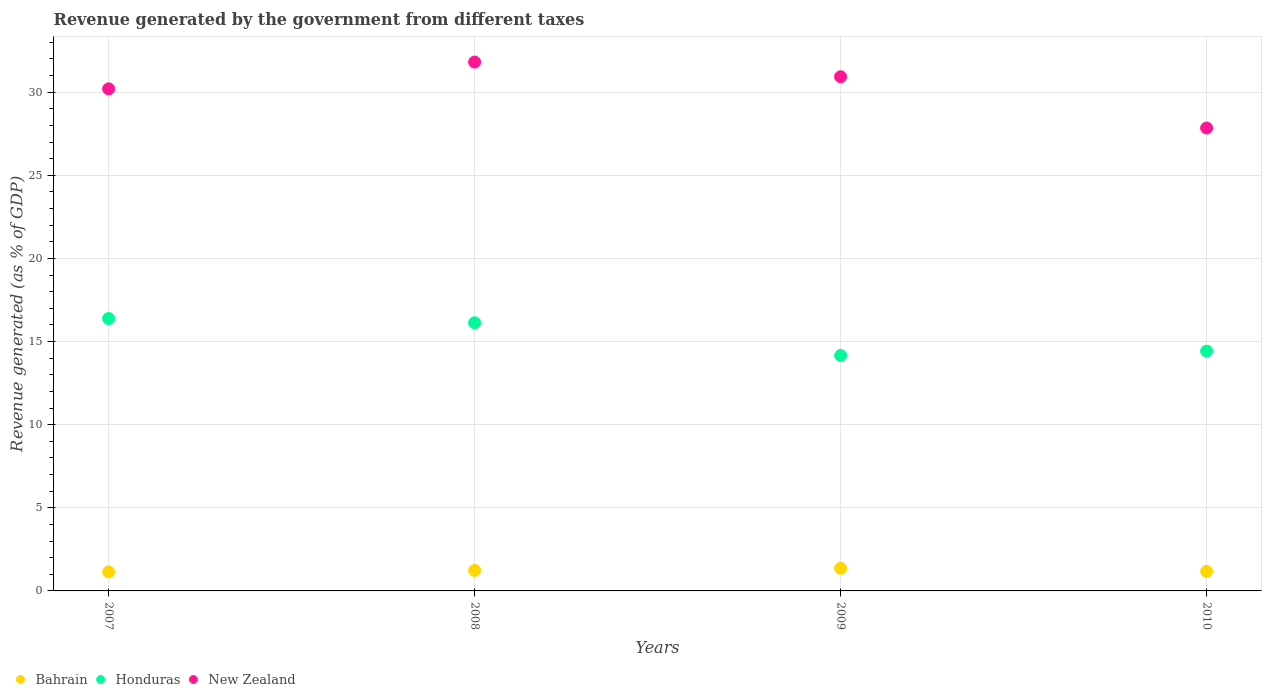Is the number of dotlines equal to the number of legend labels?
Your answer should be very brief. Yes. What is the revenue generated by the government in New Zealand in 2008?
Make the answer very short. 31.81. Across all years, what is the maximum revenue generated by the government in Honduras?
Provide a short and direct response. 16.39. Across all years, what is the minimum revenue generated by the government in Bahrain?
Offer a terse response. 1.15. In which year was the revenue generated by the government in Honduras maximum?
Offer a very short reply. 2007. In which year was the revenue generated by the government in Honduras minimum?
Offer a terse response. 2009. What is the total revenue generated by the government in Bahrain in the graph?
Make the answer very short. 4.92. What is the difference between the revenue generated by the government in New Zealand in 2008 and that in 2009?
Provide a short and direct response. 0.88. What is the difference between the revenue generated by the government in Bahrain in 2010 and the revenue generated by the government in New Zealand in 2007?
Keep it short and to the point. -29.02. What is the average revenue generated by the government in Honduras per year?
Offer a terse response. 15.28. In the year 2009, what is the difference between the revenue generated by the government in New Zealand and revenue generated by the government in Honduras?
Your response must be concise. 16.77. What is the ratio of the revenue generated by the government in New Zealand in 2007 to that in 2008?
Your answer should be very brief. 0.95. Is the revenue generated by the government in Honduras in 2007 less than that in 2008?
Your response must be concise. No. What is the difference between the highest and the second highest revenue generated by the government in New Zealand?
Make the answer very short. 0.88. What is the difference between the highest and the lowest revenue generated by the government in New Zealand?
Your answer should be compact. 3.96. Is the sum of the revenue generated by the government in New Zealand in 2007 and 2009 greater than the maximum revenue generated by the government in Bahrain across all years?
Your response must be concise. Yes. Are the values on the major ticks of Y-axis written in scientific E-notation?
Keep it short and to the point. No. Does the graph contain grids?
Provide a succinct answer. Yes. Where does the legend appear in the graph?
Keep it short and to the point. Bottom left. What is the title of the graph?
Provide a succinct answer. Revenue generated by the government from different taxes. What is the label or title of the Y-axis?
Ensure brevity in your answer.  Revenue generated (as % of GDP). What is the Revenue generated (as % of GDP) in Bahrain in 2007?
Your answer should be compact. 1.15. What is the Revenue generated (as % of GDP) in Honduras in 2007?
Make the answer very short. 16.39. What is the Revenue generated (as % of GDP) of New Zealand in 2007?
Keep it short and to the point. 30.2. What is the Revenue generated (as % of GDP) of Bahrain in 2008?
Provide a short and direct response. 1.24. What is the Revenue generated (as % of GDP) in Honduras in 2008?
Provide a succinct answer. 16.13. What is the Revenue generated (as % of GDP) in New Zealand in 2008?
Your answer should be very brief. 31.81. What is the Revenue generated (as % of GDP) in Bahrain in 2009?
Offer a very short reply. 1.36. What is the Revenue generated (as % of GDP) of Honduras in 2009?
Offer a terse response. 14.16. What is the Revenue generated (as % of GDP) in New Zealand in 2009?
Ensure brevity in your answer.  30.93. What is the Revenue generated (as % of GDP) in Bahrain in 2010?
Your answer should be compact. 1.18. What is the Revenue generated (as % of GDP) of Honduras in 2010?
Provide a short and direct response. 14.43. What is the Revenue generated (as % of GDP) of New Zealand in 2010?
Ensure brevity in your answer.  27.85. Across all years, what is the maximum Revenue generated (as % of GDP) in Bahrain?
Make the answer very short. 1.36. Across all years, what is the maximum Revenue generated (as % of GDP) in Honduras?
Your response must be concise. 16.39. Across all years, what is the maximum Revenue generated (as % of GDP) in New Zealand?
Provide a succinct answer. 31.81. Across all years, what is the minimum Revenue generated (as % of GDP) in Bahrain?
Offer a terse response. 1.15. Across all years, what is the minimum Revenue generated (as % of GDP) in Honduras?
Your answer should be compact. 14.16. Across all years, what is the minimum Revenue generated (as % of GDP) of New Zealand?
Keep it short and to the point. 27.85. What is the total Revenue generated (as % of GDP) of Bahrain in the graph?
Provide a short and direct response. 4.92. What is the total Revenue generated (as % of GDP) in Honduras in the graph?
Offer a very short reply. 61.1. What is the total Revenue generated (as % of GDP) in New Zealand in the graph?
Your answer should be compact. 120.79. What is the difference between the Revenue generated (as % of GDP) in Bahrain in 2007 and that in 2008?
Keep it short and to the point. -0.09. What is the difference between the Revenue generated (as % of GDP) of Honduras in 2007 and that in 2008?
Your answer should be compact. 0.25. What is the difference between the Revenue generated (as % of GDP) in New Zealand in 2007 and that in 2008?
Make the answer very short. -1.61. What is the difference between the Revenue generated (as % of GDP) of Bahrain in 2007 and that in 2009?
Give a very brief answer. -0.22. What is the difference between the Revenue generated (as % of GDP) of Honduras in 2007 and that in 2009?
Give a very brief answer. 2.22. What is the difference between the Revenue generated (as % of GDP) of New Zealand in 2007 and that in 2009?
Provide a short and direct response. -0.73. What is the difference between the Revenue generated (as % of GDP) in Bahrain in 2007 and that in 2010?
Provide a short and direct response. -0.03. What is the difference between the Revenue generated (as % of GDP) in Honduras in 2007 and that in 2010?
Give a very brief answer. 1.96. What is the difference between the Revenue generated (as % of GDP) of New Zealand in 2007 and that in 2010?
Your answer should be compact. 2.35. What is the difference between the Revenue generated (as % of GDP) of Bahrain in 2008 and that in 2009?
Give a very brief answer. -0.13. What is the difference between the Revenue generated (as % of GDP) in Honduras in 2008 and that in 2009?
Provide a short and direct response. 1.97. What is the difference between the Revenue generated (as % of GDP) in New Zealand in 2008 and that in 2009?
Keep it short and to the point. 0.88. What is the difference between the Revenue generated (as % of GDP) of Bahrain in 2008 and that in 2010?
Your answer should be compact. 0.06. What is the difference between the Revenue generated (as % of GDP) of Honduras in 2008 and that in 2010?
Make the answer very short. 1.71. What is the difference between the Revenue generated (as % of GDP) in New Zealand in 2008 and that in 2010?
Your answer should be compact. 3.96. What is the difference between the Revenue generated (as % of GDP) in Bahrain in 2009 and that in 2010?
Offer a very short reply. 0.19. What is the difference between the Revenue generated (as % of GDP) in Honduras in 2009 and that in 2010?
Ensure brevity in your answer.  -0.26. What is the difference between the Revenue generated (as % of GDP) of New Zealand in 2009 and that in 2010?
Keep it short and to the point. 3.08. What is the difference between the Revenue generated (as % of GDP) of Bahrain in 2007 and the Revenue generated (as % of GDP) of Honduras in 2008?
Ensure brevity in your answer.  -14.99. What is the difference between the Revenue generated (as % of GDP) in Bahrain in 2007 and the Revenue generated (as % of GDP) in New Zealand in 2008?
Your answer should be compact. -30.67. What is the difference between the Revenue generated (as % of GDP) in Honduras in 2007 and the Revenue generated (as % of GDP) in New Zealand in 2008?
Your answer should be very brief. -15.43. What is the difference between the Revenue generated (as % of GDP) in Bahrain in 2007 and the Revenue generated (as % of GDP) in Honduras in 2009?
Provide a succinct answer. -13.02. What is the difference between the Revenue generated (as % of GDP) in Bahrain in 2007 and the Revenue generated (as % of GDP) in New Zealand in 2009?
Offer a terse response. -29.78. What is the difference between the Revenue generated (as % of GDP) in Honduras in 2007 and the Revenue generated (as % of GDP) in New Zealand in 2009?
Provide a short and direct response. -14.54. What is the difference between the Revenue generated (as % of GDP) of Bahrain in 2007 and the Revenue generated (as % of GDP) of Honduras in 2010?
Provide a short and direct response. -13.28. What is the difference between the Revenue generated (as % of GDP) in Bahrain in 2007 and the Revenue generated (as % of GDP) in New Zealand in 2010?
Give a very brief answer. -26.7. What is the difference between the Revenue generated (as % of GDP) of Honduras in 2007 and the Revenue generated (as % of GDP) of New Zealand in 2010?
Make the answer very short. -11.46. What is the difference between the Revenue generated (as % of GDP) in Bahrain in 2008 and the Revenue generated (as % of GDP) in Honduras in 2009?
Give a very brief answer. -12.93. What is the difference between the Revenue generated (as % of GDP) of Bahrain in 2008 and the Revenue generated (as % of GDP) of New Zealand in 2009?
Your response must be concise. -29.69. What is the difference between the Revenue generated (as % of GDP) of Honduras in 2008 and the Revenue generated (as % of GDP) of New Zealand in 2009?
Offer a very short reply. -14.8. What is the difference between the Revenue generated (as % of GDP) in Bahrain in 2008 and the Revenue generated (as % of GDP) in Honduras in 2010?
Your response must be concise. -13.19. What is the difference between the Revenue generated (as % of GDP) in Bahrain in 2008 and the Revenue generated (as % of GDP) in New Zealand in 2010?
Give a very brief answer. -26.61. What is the difference between the Revenue generated (as % of GDP) in Honduras in 2008 and the Revenue generated (as % of GDP) in New Zealand in 2010?
Your answer should be very brief. -11.72. What is the difference between the Revenue generated (as % of GDP) of Bahrain in 2009 and the Revenue generated (as % of GDP) of Honduras in 2010?
Your response must be concise. -13.06. What is the difference between the Revenue generated (as % of GDP) in Bahrain in 2009 and the Revenue generated (as % of GDP) in New Zealand in 2010?
Make the answer very short. -26.48. What is the difference between the Revenue generated (as % of GDP) in Honduras in 2009 and the Revenue generated (as % of GDP) in New Zealand in 2010?
Make the answer very short. -13.68. What is the average Revenue generated (as % of GDP) in Bahrain per year?
Provide a succinct answer. 1.23. What is the average Revenue generated (as % of GDP) in Honduras per year?
Your answer should be very brief. 15.28. What is the average Revenue generated (as % of GDP) in New Zealand per year?
Offer a terse response. 30.2. In the year 2007, what is the difference between the Revenue generated (as % of GDP) of Bahrain and Revenue generated (as % of GDP) of Honduras?
Provide a short and direct response. -15.24. In the year 2007, what is the difference between the Revenue generated (as % of GDP) in Bahrain and Revenue generated (as % of GDP) in New Zealand?
Offer a very short reply. -29.06. In the year 2007, what is the difference between the Revenue generated (as % of GDP) of Honduras and Revenue generated (as % of GDP) of New Zealand?
Provide a succinct answer. -13.82. In the year 2008, what is the difference between the Revenue generated (as % of GDP) in Bahrain and Revenue generated (as % of GDP) in Honduras?
Keep it short and to the point. -14.89. In the year 2008, what is the difference between the Revenue generated (as % of GDP) of Bahrain and Revenue generated (as % of GDP) of New Zealand?
Provide a short and direct response. -30.58. In the year 2008, what is the difference between the Revenue generated (as % of GDP) of Honduras and Revenue generated (as % of GDP) of New Zealand?
Provide a succinct answer. -15.68. In the year 2009, what is the difference between the Revenue generated (as % of GDP) in Bahrain and Revenue generated (as % of GDP) in Honduras?
Make the answer very short. -12.8. In the year 2009, what is the difference between the Revenue generated (as % of GDP) in Bahrain and Revenue generated (as % of GDP) in New Zealand?
Offer a terse response. -29.57. In the year 2009, what is the difference between the Revenue generated (as % of GDP) of Honduras and Revenue generated (as % of GDP) of New Zealand?
Make the answer very short. -16.77. In the year 2010, what is the difference between the Revenue generated (as % of GDP) in Bahrain and Revenue generated (as % of GDP) in Honduras?
Provide a short and direct response. -13.25. In the year 2010, what is the difference between the Revenue generated (as % of GDP) of Bahrain and Revenue generated (as % of GDP) of New Zealand?
Give a very brief answer. -26.67. In the year 2010, what is the difference between the Revenue generated (as % of GDP) in Honduras and Revenue generated (as % of GDP) in New Zealand?
Ensure brevity in your answer.  -13.42. What is the ratio of the Revenue generated (as % of GDP) in Bahrain in 2007 to that in 2008?
Your response must be concise. 0.93. What is the ratio of the Revenue generated (as % of GDP) of Honduras in 2007 to that in 2008?
Your answer should be compact. 1.02. What is the ratio of the Revenue generated (as % of GDP) in New Zealand in 2007 to that in 2008?
Give a very brief answer. 0.95. What is the ratio of the Revenue generated (as % of GDP) in Bahrain in 2007 to that in 2009?
Your answer should be very brief. 0.84. What is the ratio of the Revenue generated (as % of GDP) in Honduras in 2007 to that in 2009?
Your response must be concise. 1.16. What is the ratio of the Revenue generated (as % of GDP) of New Zealand in 2007 to that in 2009?
Offer a terse response. 0.98. What is the ratio of the Revenue generated (as % of GDP) in Bahrain in 2007 to that in 2010?
Ensure brevity in your answer.  0.97. What is the ratio of the Revenue generated (as % of GDP) of Honduras in 2007 to that in 2010?
Keep it short and to the point. 1.14. What is the ratio of the Revenue generated (as % of GDP) in New Zealand in 2007 to that in 2010?
Your answer should be compact. 1.08. What is the ratio of the Revenue generated (as % of GDP) of Bahrain in 2008 to that in 2009?
Keep it short and to the point. 0.91. What is the ratio of the Revenue generated (as % of GDP) of Honduras in 2008 to that in 2009?
Ensure brevity in your answer.  1.14. What is the ratio of the Revenue generated (as % of GDP) of New Zealand in 2008 to that in 2009?
Your response must be concise. 1.03. What is the ratio of the Revenue generated (as % of GDP) in Bahrain in 2008 to that in 2010?
Your response must be concise. 1.05. What is the ratio of the Revenue generated (as % of GDP) in Honduras in 2008 to that in 2010?
Your response must be concise. 1.12. What is the ratio of the Revenue generated (as % of GDP) of New Zealand in 2008 to that in 2010?
Your answer should be compact. 1.14. What is the ratio of the Revenue generated (as % of GDP) of Bahrain in 2009 to that in 2010?
Offer a terse response. 1.16. What is the ratio of the Revenue generated (as % of GDP) in Honduras in 2009 to that in 2010?
Your response must be concise. 0.98. What is the ratio of the Revenue generated (as % of GDP) of New Zealand in 2009 to that in 2010?
Your response must be concise. 1.11. What is the difference between the highest and the second highest Revenue generated (as % of GDP) in Bahrain?
Your answer should be compact. 0.13. What is the difference between the highest and the second highest Revenue generated (as % of GDP) in Honduras?
Keep it short and to the point. 0.25. What is the difference between the highest and the second highest Revenue generated (as % of GDP) in New Zealand?
Provide a succinct answer. 0.88. What is the difference between the highest and the lowest Revenue generated (as % of GDP) of Bahrain?
Offer a terse response. 0.22. What is the difference between the highest and the lowest Revenue generated (as % of GDP) in Honduras?
Give a very brief answer. 2.22. What is the difference between the highest and the lowest Revenue generated (as % of GDP) in New Zealand?
Offer a terse response. 3.96. 